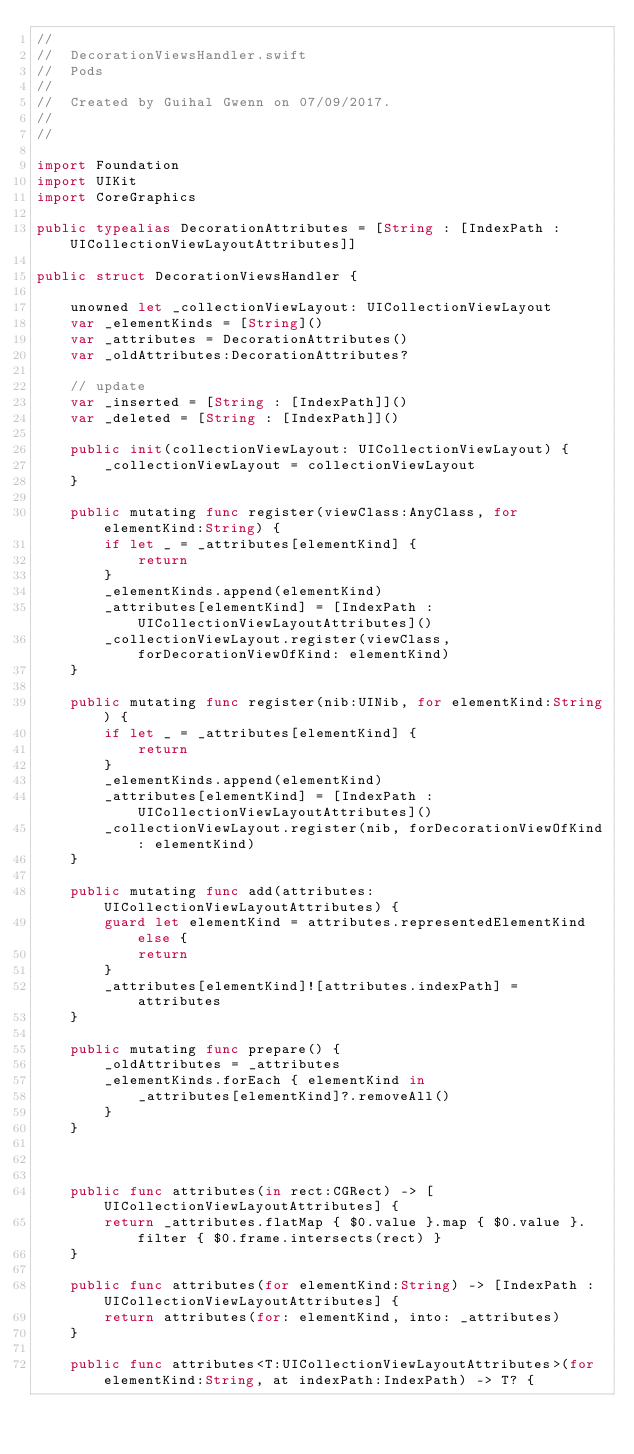<code> <loc_0><loc_0><loc_500><loc_500><_Swift_>//
//  DecorationViewsHandler.swift
//  Pods
//
//  Created by Guihal Gwenn on 07/09/2017.
//
//

import Foundation
import UIKit
import CoreGraphics

public typealias DecorationAttributes = [String : [IndexPath : UICollectionViewLayoutAttributes]]

public struct DecorationViewsHandler {
    
    unowned let _collectionViewLayout: UICollectionViewLayout
    var _elementKinds = [String]()
    var _attributes = DecorationAttributes()
    var _oldAttributes:DecorationAttributes?
    
    // update
    var _inserted = [String : [IndexPath]]()
    var _deleted = [String : [IndexPath]]()
    
    public init(collectionViewLayout: UICollectionViewLayout) {
        _collectionViewLayout = collectionViewLayout
    }
    
    public mutating func register(viewClass:AnyClass, for elementKind:String) {
        if let _ = _attributes[elementKind] {
            return
        }
        _elementKinds.append(elementKind)
        _attributes[elementKind] = [IndexPath : UICollectionViewLayoutAttributes]()
        _collectionViewLayout.register(viewClass, forDecorationViewOfKind: elementKind)
    }
    
    public mutating func register(nib:UINib, for elementKind:String) {
        if let _ = _attributes[elementKind] {
            return
        }
        _elementKinds.append(elementKind)
        _attributes[elementKind] = [IndexPath : UICollectionViewLayoutAttributes]()
        _collectionViewLayout.register(nib, forDecorationViewOfKind: elementKind)
    }
    
    public mutating func add(attributes:UICollectionViewLayoutAttributes) {
        guard let elementKind = attributes.representedElementKind else {
            return
        }
        _attributes[elementKind]![attributes.indexPath] = attributes
    }
    
    public mutating func prepare() {
        _oldAttributes = _attributes
        _elementKinds.forEach { elementKind in
            _attributes[elementKind]?.removeAll()
        }
    }
    
    
    
    public func attributes(in rect:CGRect) -> [UICollectionViewLayoutAttributes] {
        return _attributes.flatMap { $0.value }.map { $0.value }.filter { $0.frame.intersects(rect) }
    }
    
    public func attributes(for elementKind:String) -> [IndexPath : UICollectionViewLayoutAttributes] {
        return attributes(for: elementKind, into: _attributes)
    }
    
    public func attributes<T:UICollectionViewLayoutAttributes>(for elementKind:String, at indexPath:IndexPath) -> T? {</code> 